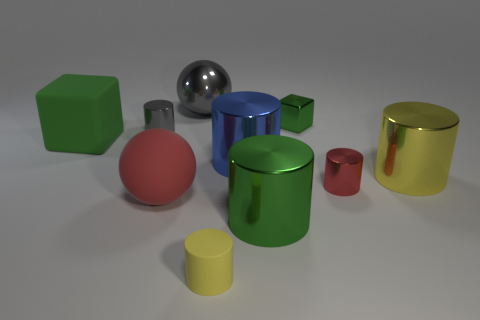How many large metal cylinders have the same color as the large matte cube?
Keep it short and to the point. 1. What number of matte things are in front of the small red cylinder and left of the big gray metallic sphere?
Your answer should be compact. 1. What is the shape of the red thing that is the same size as the green matte object?
Provide a short and direct response. Sphere. How big is the yellow matte cylinder?
Offer a terse response. Small. What is the material of the green block to the left of the matte thing that is to the right of the ball behind the shiny cube?
Your answer should be very brief. Rubber. There is a ball that is made of the same material as the large green cylinder; what color is it?
Keep it short and to the point. Gray. How many large metal cylinders are behind the green object in front of the green cube that is on the left side of the big green metallic cylinder?
Make the answer very short. 2. What material is the tiny object that is the same color as the rubber ball?
Make the answer very short. Metal. What number of things are tiny things on the right side of the green metal block or green metal cubes?
Make the answer very short. 2. There is a small object on the left side of the rubber cylinder; is its color the same as the large metal ball?
Provide a short and direct response. Yes. 